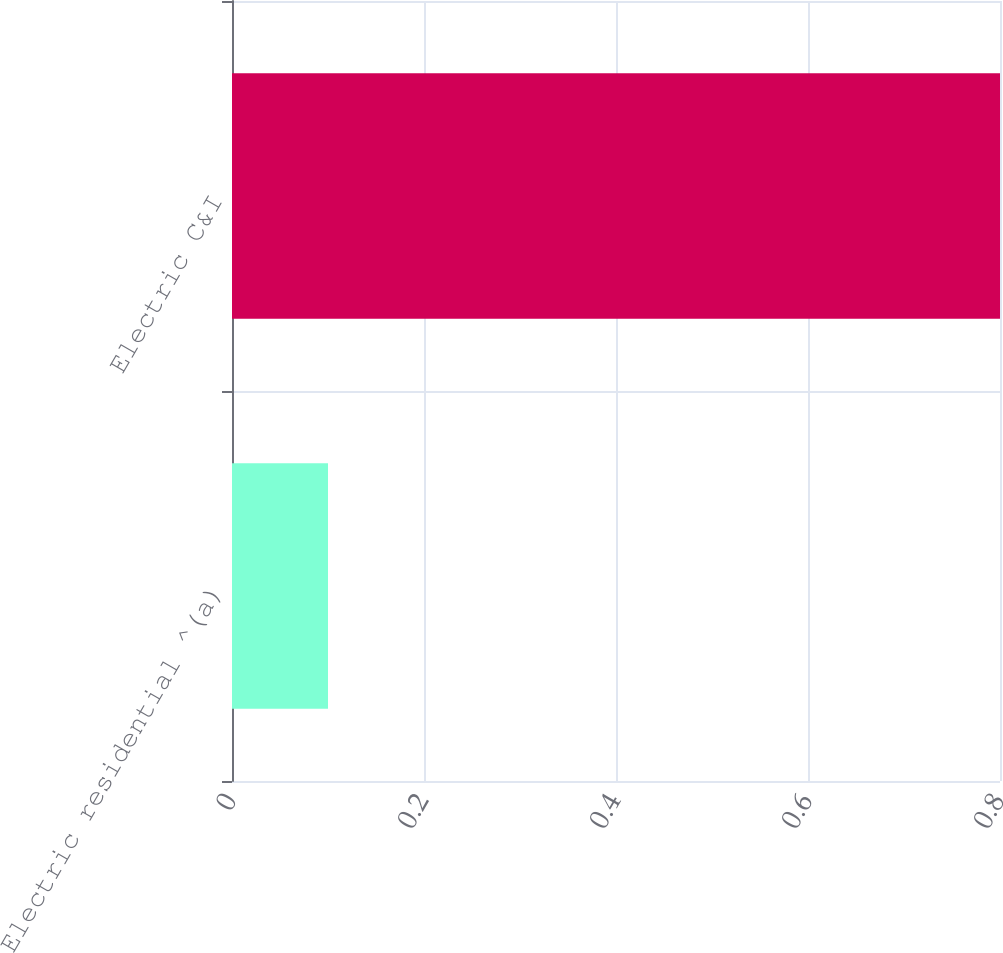Convert chart to OTSL. <chart><loc_0><loc_0><loc_500><loc_500><bar_chart><fcel>Electric residential ^(a)<fcel>Electric C&I<nl><fcel>0.1<fcel>0.8<nl></chart> 